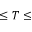Convert formula to latex. <formula><loc_0><loc_0><loc_500><loc_500>\leq T \leq</formula> 